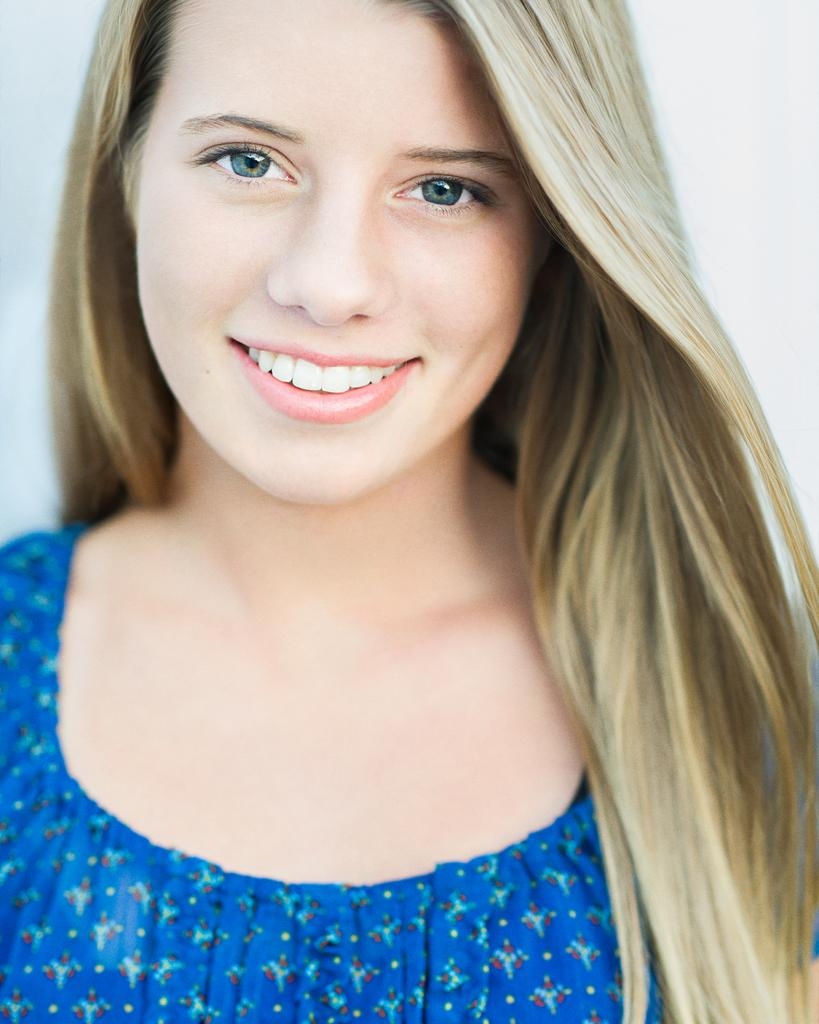Who is present in the image? There is a woman in the image. What is the woman doing in the image? The woman is smiling in the image. What is the woman wearing in the image? The woman is wearing a blue top in the image. What advice does the woman give in the image? There is no indication in the image that the woman is giving advice, so it cannot be determined from the picture. 